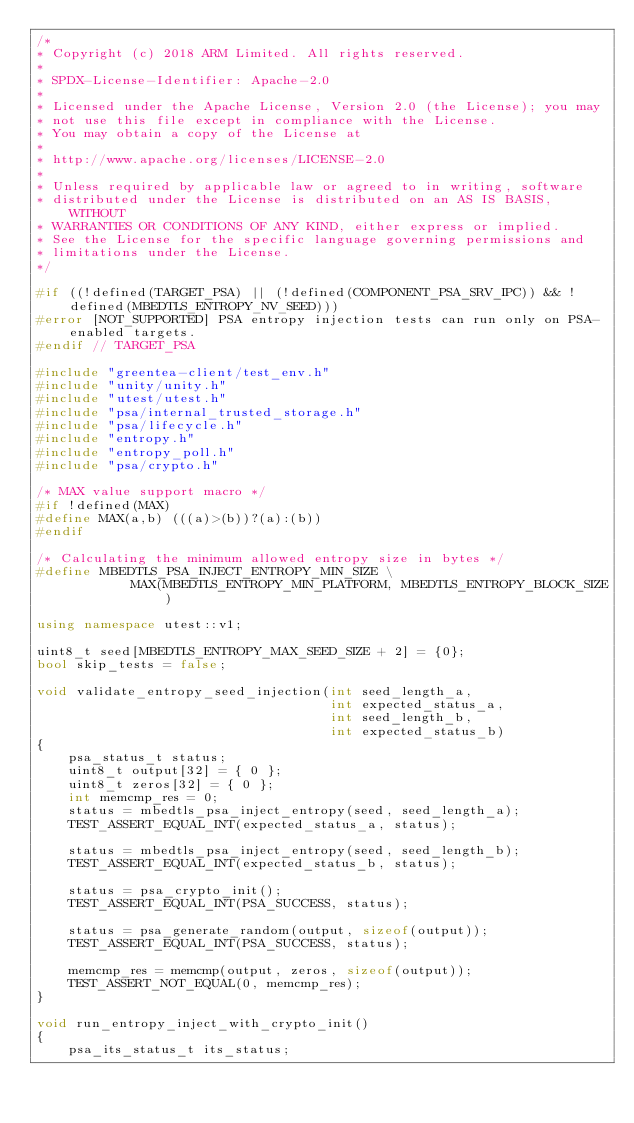Convert code to text. <code><loc_0><loc_0><loc_500><loc_500><_C++_>/*
* Copyright (c) 2018 ARM Limited. All rights reserved.
*
* SPDX-License-Identifier: Apache-2.0
*
* Licensed under the Apache License, Version 2.0 (the License); you may
* not use this file except in compliance with the License.
* You may obtain a copy of the License at
*
* http://www.apache.org/licenses/LICENSE-2.0
*
* Unless required by applicable law or agreed to in writing, software
* distributed under the License is distributed on an AS IS BASIS, WITHOUT
* WARRANTIES OR CONDITIONS OF ANY KIND, either express or implied.
* See the License for the specific language governing permissions and
* limitations under the License.
*/

#if ((!defined(TARGET_PSA) || (!defined(COMPONENT_PSA_SRV_IPC)) && !defined(MBEDTLS_ENTROPY_NV_SEED)))
#error [NOT_SUPPORTED] PSA entropy injection tests can run only on PSA-enabled targets.
#endif // TARGET_PSA

#include "greentea-client/test_env.h"
#include "unity/unity.h"
#include "utest/utest.h"
#include "psa/internal_trusted_storage.h"
#include "psa/lifecycle.h"
#include "entropy.h"
#include "entropy_poll.h"
#include "psa/crypto.h"

/* MAX value support macro */
#if !defined(MAX)
#define MAX(a,b) (((a)>(b))?(a):(b))
#endif

/* Calculating the minimum allowed entropy size in bytes */
#define MBEDTLS_PSA_INJECT_ENTROPY_MIN_SIZE \
            MAX(MBEDTLS_ENTROPY_MIN_PLATFORM, MBEDTLS_ENTROPY_BLOCK_SIZE)

using namespace utest::v1;

uint8_t seed[MBEDTLS_ENTROPY_MAX_SEED_SIZE + 2] = {0};
bool skip_tests = false;

void validate_entropy_seed_injection(int seed_length_a,
                                     int expected_status_a,
                                     int seed_length_b,
                                     int expected_status_b)
{
    psa_status_t status;
    uint8_t output[32] = { 0 };
    uint8_t zeros[32] = { 0 };
    int memcmp_res = 0;
    status = mbedtls_psa_inject_entropy(seed, seed_length_a);
    TEST_ASSERT_EQUAL_INT(expected_status_a, status);

    status = mbedtls_psa_inject_entropy(seed, seed_length_b);
    TEST_ASSERT_EQUAL_INT(expected_status_b, status);

    status = psa_crypto_init();
    TEST_ASSERT_EQUAL_INT(PSA_SUCCESS, status);

    status = psa_generate_random(output, sizeof(output));
    TEST_ASSERT_EQUAL_INT(PSA_SUCCESS, status);

    memcmp_res = memcmp(output, zeros, sizeof(output));
    TEST_ASSERT_NOT_EQUAL(0, memcmp_res);
}

void run_entropy_inject_with_crypto_init()
{
    psa_its_status_t its_status;</code> 